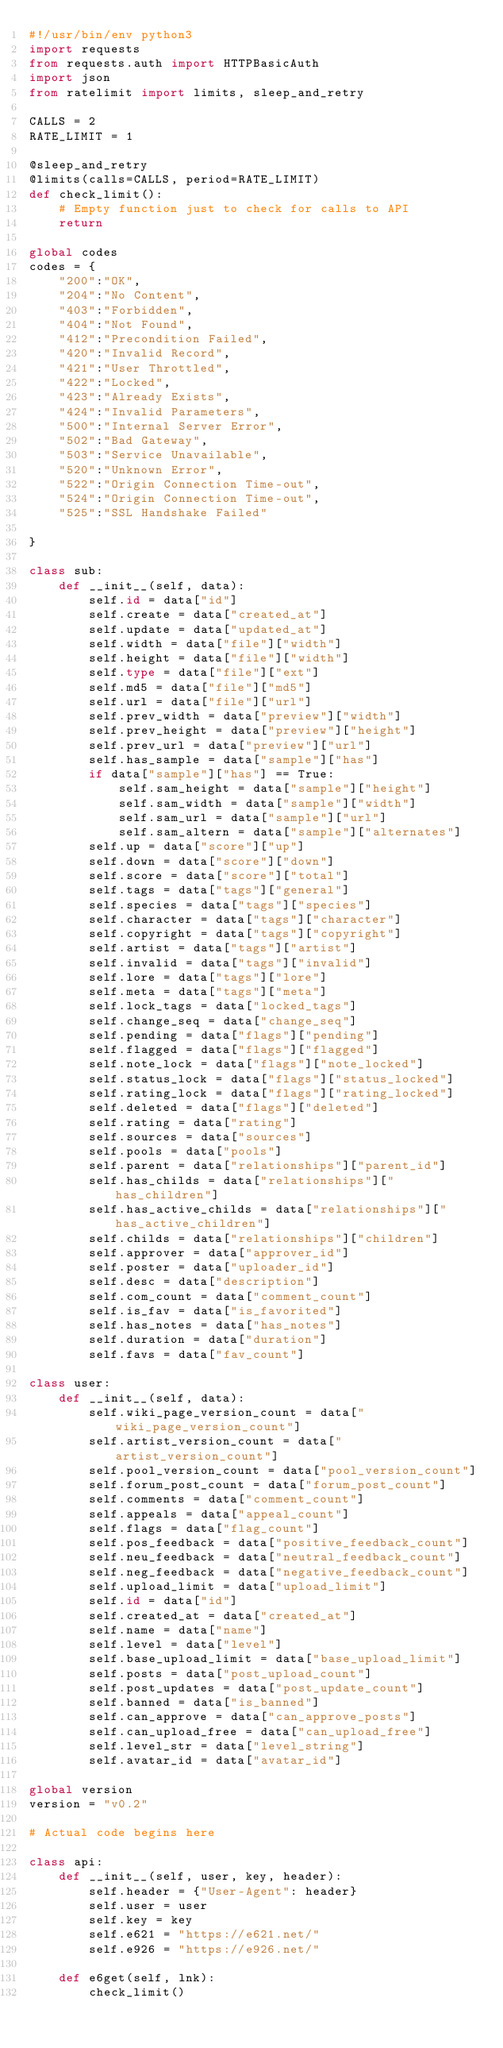<code> <loc_0><loc_0><loc_500><loc_500><_Python_>#!/usr/bin/env python3
import requests
from requests.auth import HTTPBasicAuth
import json
from ratelimit import limits, sleep_and_retry

CALLS = 2
RATE_LIMIT = 1

@sleep_and_retry
@limits(calls=CALLS, period=RATE_LIMIT)
def check_limit():
    # Empty function just to check for calls to API
    return

global codes
codes = {
    "200":"OK",
    "204":"No Content",
    "403":"Forbidden",
    "404":"Not Found",
    "412":"Precondition Failed",
    "420":"Invalid Record",
    "421":"User Throttled",
    "422":"Locked",
    "423":"Already Exists",
    "424":"Invalid Parameters",
    "500":"Internal Server Error",
    "502":"Bad Gateway",
    "503":"Service Unavailable",
    "520":"Unknown Error",
    "522":"Origin Connection Time-out",
    "524":"Origin Connection Time-out",
    "525":"SSL Handshake Failed"
    
}

class sub:
    def __init__(self, data):
        self.id = data["id"]
        self.create = data["created_at"]
        self.update = data["updated_at"]
        self.width = data["file"]["width"]
        self.height = data["file"]["width"]
        self.type = data["file"]["ext"]
        self.md5 = data["file"]["md5"] 
        self.url = data["file"]["url"]
        self.prev_width = data["preview"]["width"]
        self.prev_height = data["preview"]["height"]
        self.prev_url = data["preview"]["url"]
        self.has_sample = data["sample"]["has"]
        if data["sample"]["has"] == True:
            self.sam_height = data["sample"]["height"]
            self.sam_width = data["sample"]["width"]
            self.sam_url = data["sample"]["url"]
            self.sam_altern = data["sample"]["alternates"]
        self.up = data["score"]["up"]
        self.down = data["score"]["down"]
        self.score = data["score"]["total"]
        self.tags = data["tags"]["general"]
        self.species = data["tags"]["species"]
        self.character = data["tags"]["character"]
        self.copyright = data["tags"]["copyright"]
        self.artist = data["tags"]["artist"]
        self.invalid = data["tags"]["invalid"]
        self.lore = data["tags"]["lore"]
        self.meta = data["tags"]["meta"]
        self.lock_tags = data["locked_tags"]
        self.change_seq = data["change_seq"]
        self.pending = data["flags"]["pending"]
        self.flagged = data["flags"]["flagged"]
        self.note_lock = data["flags"]["note_locked"]
        self.status_lock = data["flags"]["status_locked"]
        self.rating_lock = data["flags"]["rating_locked"]
        self.deleted = data["flags"]["deleted"]
        self.rating = data["rating"]
        self.sources = data["sources"]
        self.pools = data["pools"]
        self.parent = data["relationships"]["parent_id"]
        self.has_childs = data["relationships"]["has_children"]
        self.has_active_childs = data["relationships"]["has_active_children"]
        self.childs = data["relationships"]["children"]
        self.approver = data["approver_id"]
        self.poster = data["uploader_id"]
        self.desc = data["description"]
        self.com_count = data["comment_count"]
        self.is_fav = data["is_favorited"]
        self.has_notes = data["has_notes"]
        self.duration = data["duration"]
        self.favs = data["fav_count"]

class user:
    def __init__(self, data):
        self.wiki_page_version_count = data["wiki_page_version_count"]
        self.artist_version_count = data["artist_version_count"]
        self.pool_version_count = data["pool_version_count"]
        self.forum_post_count = data["forum_post_count"]
        self.comments = data["comment_count"]
        self.appeals = data["appeal_count"]
        self.flags = data["flag_count"]
        self.pos_feedback = data["positive_feedback_count"]
        self.neu_feedback = data["neutral_feedback_count"]
        self.neg_feedback = data["negative_feedback_count"]
        self.upload_limit = data["upload_limit"]
        self.id = data["id"]
        self.created_at = data["created_at"]
        self.name = data["name"]
        self.level = data["level"]
        self.base_upload_limit = data["base_upload_limit"]
        self.posts = data["post_upload_count"]
        self.post_updates = data["post_update_count"]
        self.banned = data["is_banned"]
        self.can_approve = data["can_approve_posts"]
        self.can_upload_free = data["can_upload_free"]
        self.level_str = data["level_string"]
        self.avatar_id = data["avatar_id"]

global version
version = "v0.2"

# Actual code begins here

class api:
    def __init__(self, user, key, header):
        self.header = {"User-Agent": header}
        self.user = user
        self.key = key
        self.e621 = "https://e621.net/"
        self.e926 = "https://e926.net/"

    def e6get(self, lnk):
        check_limit()</code> 